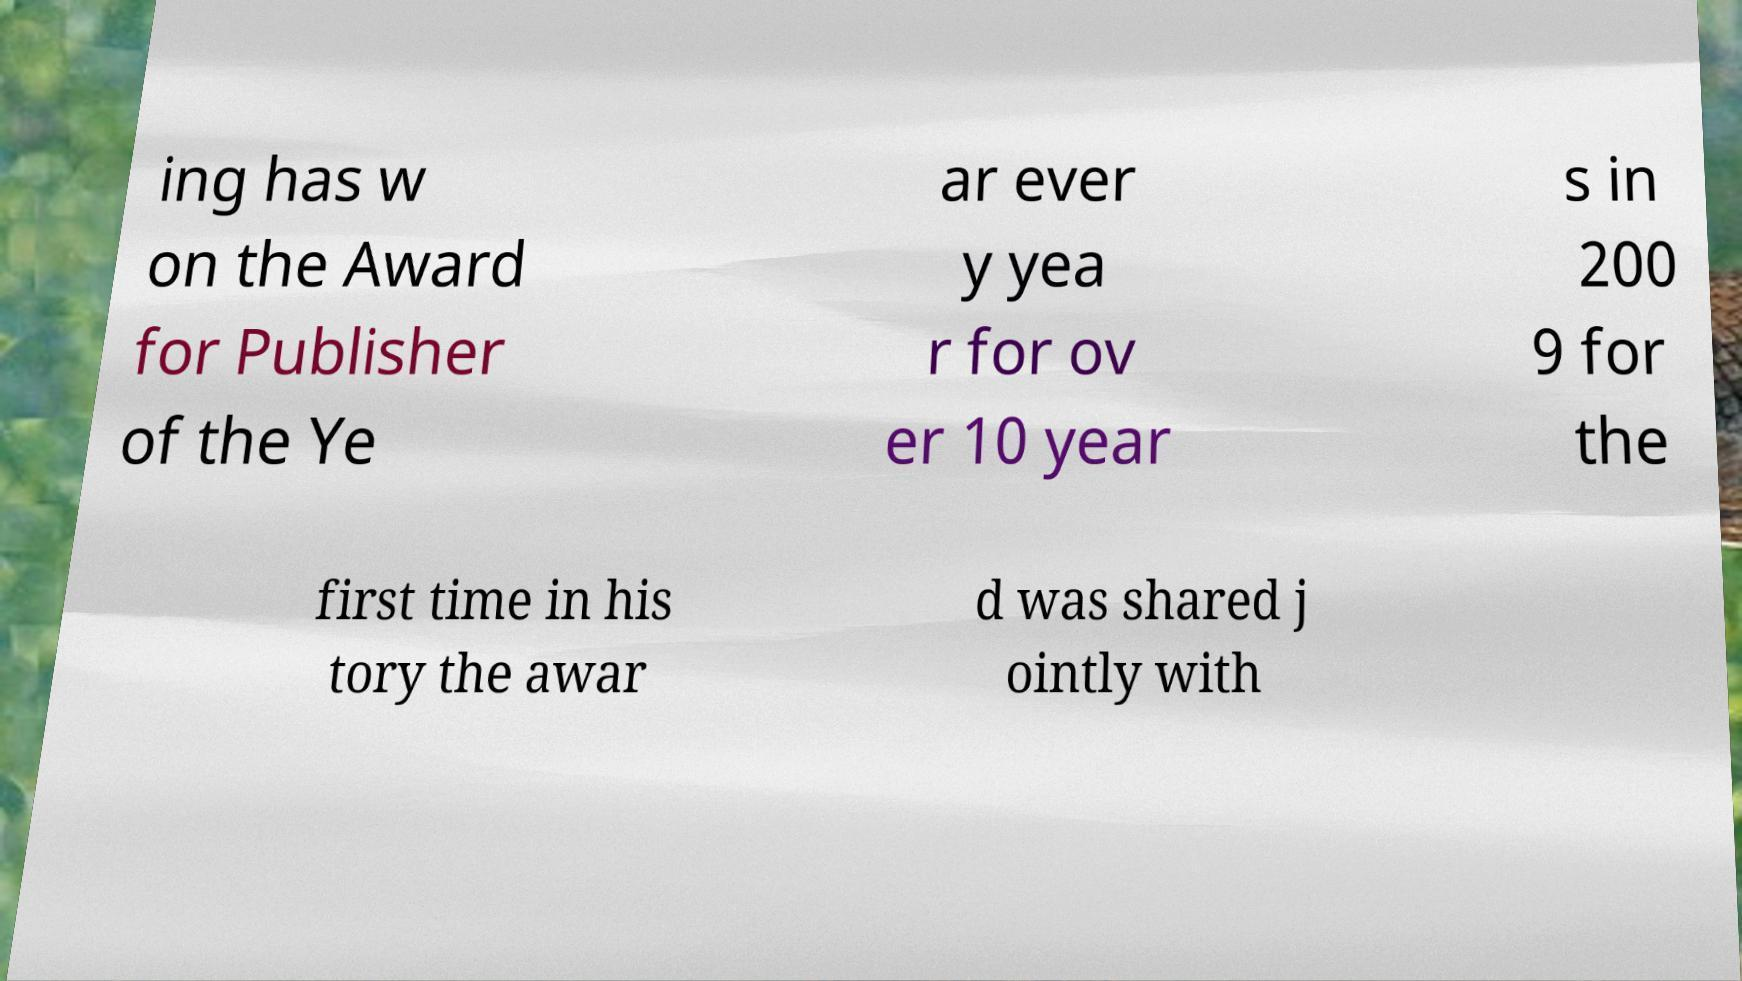Can you read and provide the text displayed in the image?This photo seems to have some interesting text. Can you extract and type it out for me? ing has w on the Award for Publisher of the Ye ar ever y yea r for ov er 10 year s in 200 9 for the first time in his tory the awar d was shared j ointly with 